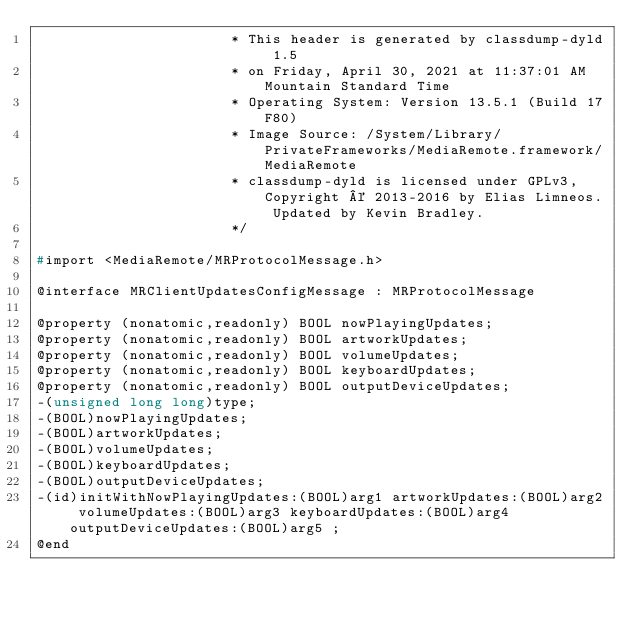<code> <loc_0><loc_0><loc_500><loc_500><_C_>                       * This header is generated by classdump-dyld 1.5
                       * on Friday, April 30, 2021 at 11:37:01 AM Mountain Standard Time
                       * Operating System: Version 13.5.1 (Build 17F80)
                       * Image Source: /System/Library/PrivateFrameworks/MediaRemote.framework/MediaRemote
                       * classdump-dyld is licensed under GPLv3, Copyright © 2013-2016 by Elias Limneos. Updated by Kevin Bradley.
                       */

#import <MediaRemote/MRProtocolMessage.h>

@interface MRClientUpdatesConfigMessage : MRProtocolMessage

@property (nonatomic,readonly) BOOL nowPlayingUpdates; 
@property (nonatomic,readonly) BOOL artworkUpdates; 
@property (nonatomic,readonly) BOOL volumeUpdates; 
@property (nonatomic,readonly) BOOL keyboardUpdates; 
@property (nonatomic,readonly) BOOL outputDeviceUpdates; 
-(unsigned long long)type;
-(BOOL)nowPlayingUpdates;
-(BOOL)artworkUpdates;
-(BOOL)volumeUpdates;
-(BOOL)keyboardUpdates;
-(BOOL)outputDeviceUpdates;
-(id)initWithNowPlayingUpdates:(BOOL)arg1 artworkUpdates:(BOOL)arg2 volumeUpdates:(BOOL)arg3 keyboardUpdates:(BOOL)arg4 outputDeviceUpdates:(BOOL)arg5 ;
@end

</code> 